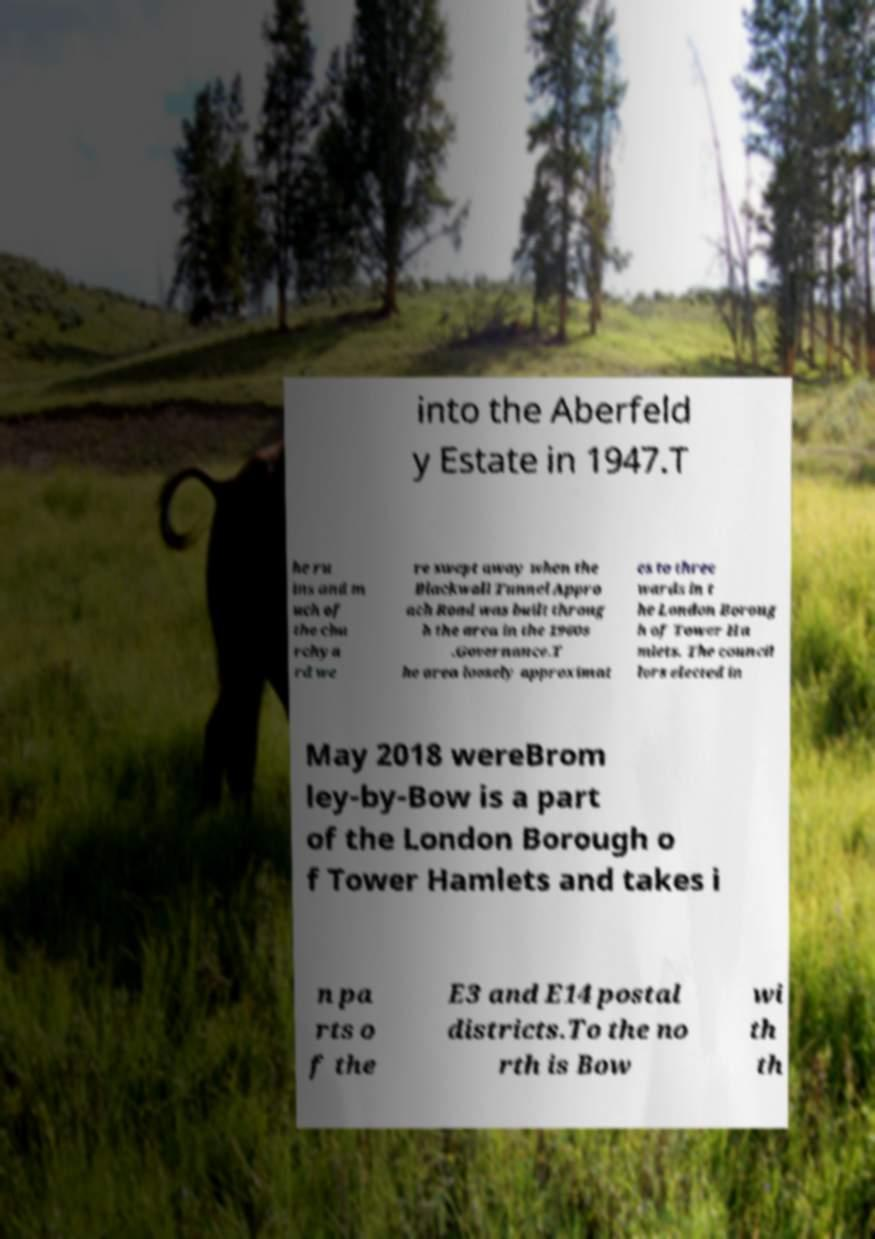Please read and relay the text visible in this image. What does it say? into the Aberfeld y Estate in 1947.T he ru ins and m uch of the chu rchya rd we re swept away when the Blackwall Tunnel Appro ach Road was built throug h the area in the 1960s .Governance.T he area loosely approximat es to three wards in t he London Boroug h of Tower Ha mlets. The council lors elected in May 2018 wereBrom ley-by-Bow is a part of the London Borough o f Tower Hamlets and takes i n pa rts o f the E3 and E14 postal districts.To the no rth is Bow wi th th 